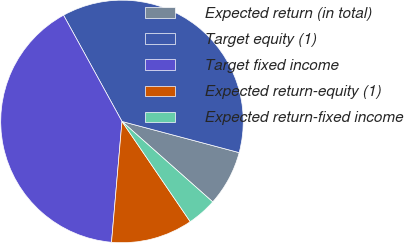Convert chart to OTSL. <chart><loc_0><loc_0><loc_500><loc_500><pie_chart><fcel>Expected return (in total)<fcel>Target equity (1)<fcel>Target fixed income<fcel>Expected return-equity (1)<fcel>Expected return-fixed income<nl><fcel>7.41%<fcel>37.14%<fcel>40.62%<fcel>10.89%<fcel>3.94%<nl></chart> 